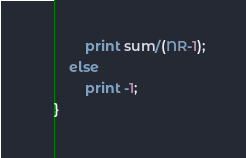<code> <loc_0><loc_0><loc_500><loc_500><_Awk_>		print sum/(NR-1); 
	else 
		print -1;
}
</code> 